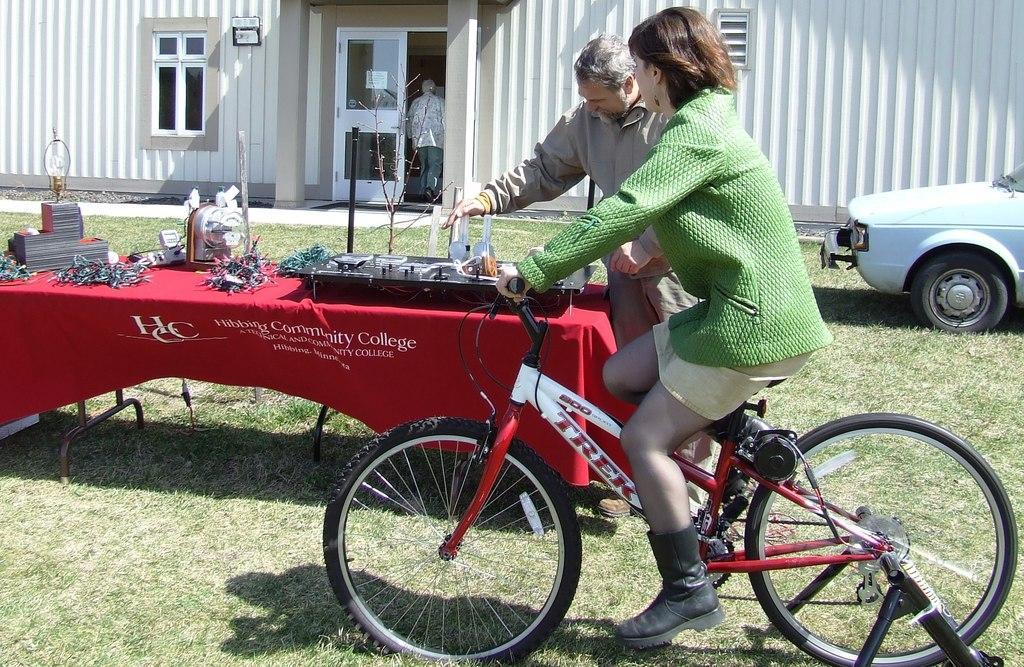How would you summarize this image in a sentence or two? This is a place where we can see a girl who is wearing green color jacket and riding a bicycle and a person beside her who is standing in front of a table on which there are some things and behind them there is a car, a door, window and a person entering the room. 